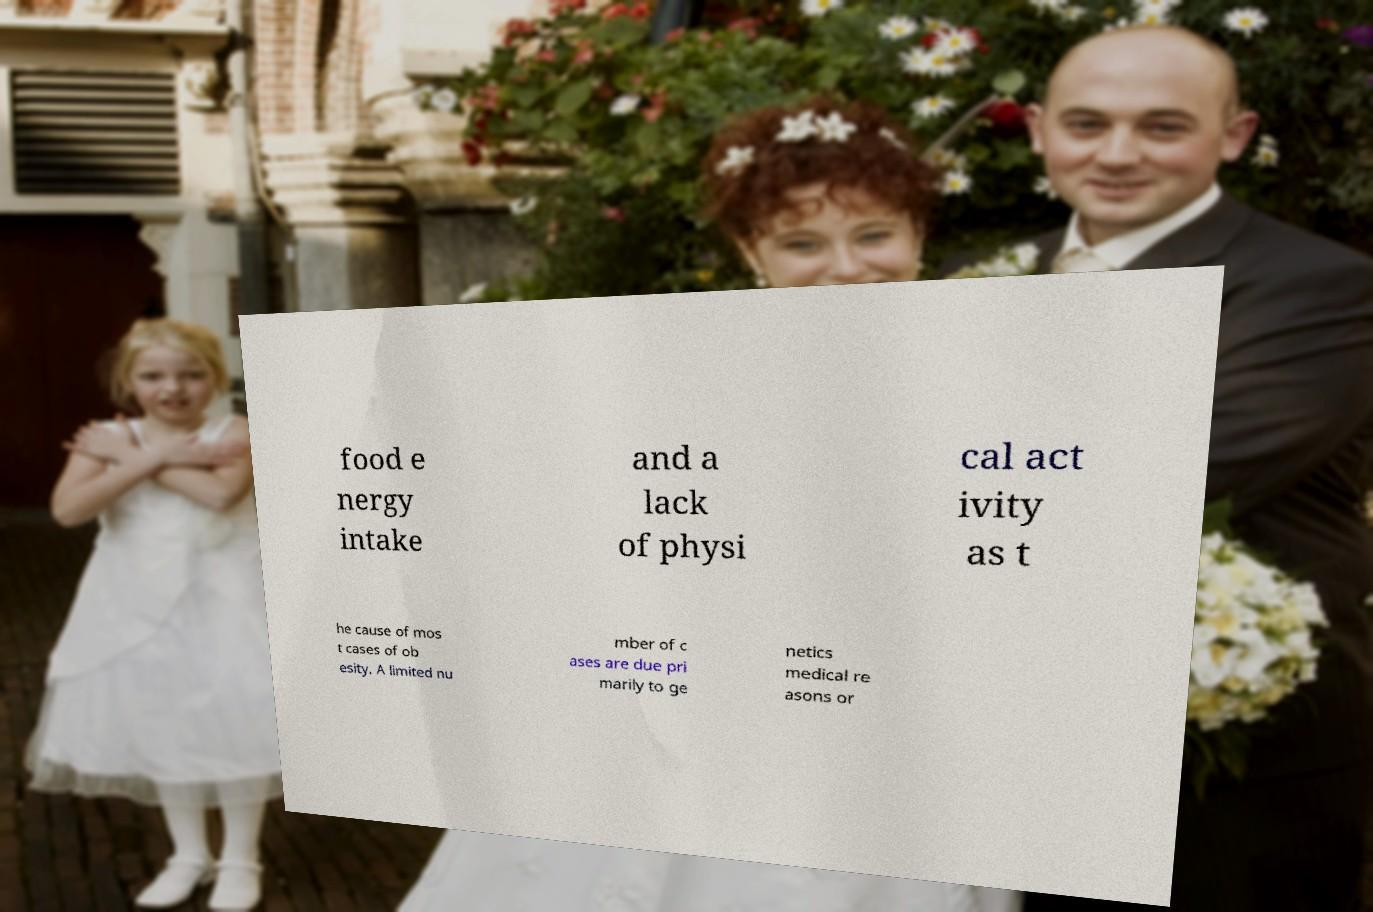Could you assist in decoding the text presented in this image and type it out clearly? food e nergy intake and a lack of physi cal act ivity as t he cause of mos t cases of ob esity. A limited nu mber of c ases are due pri marily to ge netics medical re asons or 